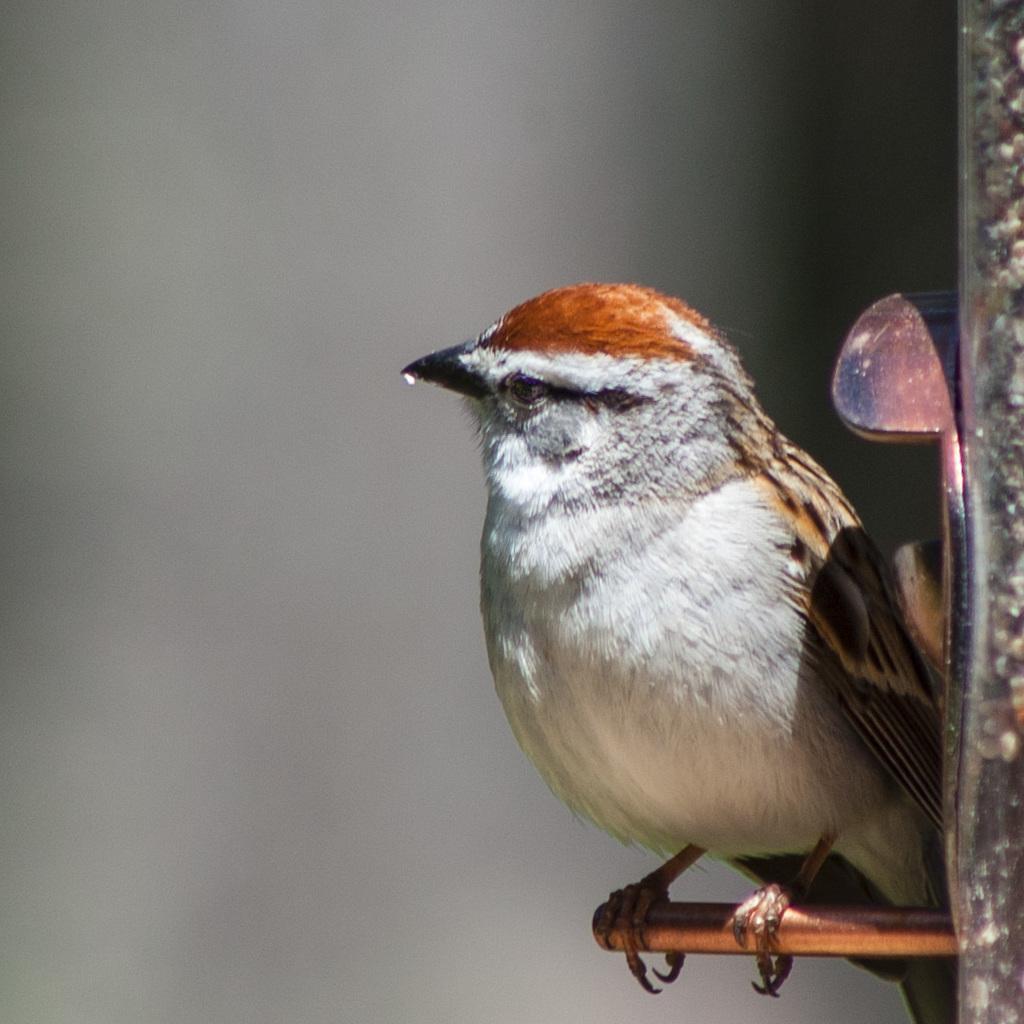How would you summarize this image in a sentence or two? In this picture, we can see a bird is standing on an object and there is a blurred background. 